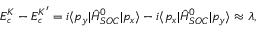<formula> <loc_0><loc_0><loc_500><loc_500>E _ { c } ^ { K } - E _ { c } ^ { K ^ { \prime } } = i \langle p _ { y } | \hat { H } _ { S O C } ^ { 0 } | p _ { x } \rangle - i \langle p _ { x } | \hat { H } _ { S O C } ^ { 0 } | p _ { y } \rangle \approx \lambda ,</formula> 